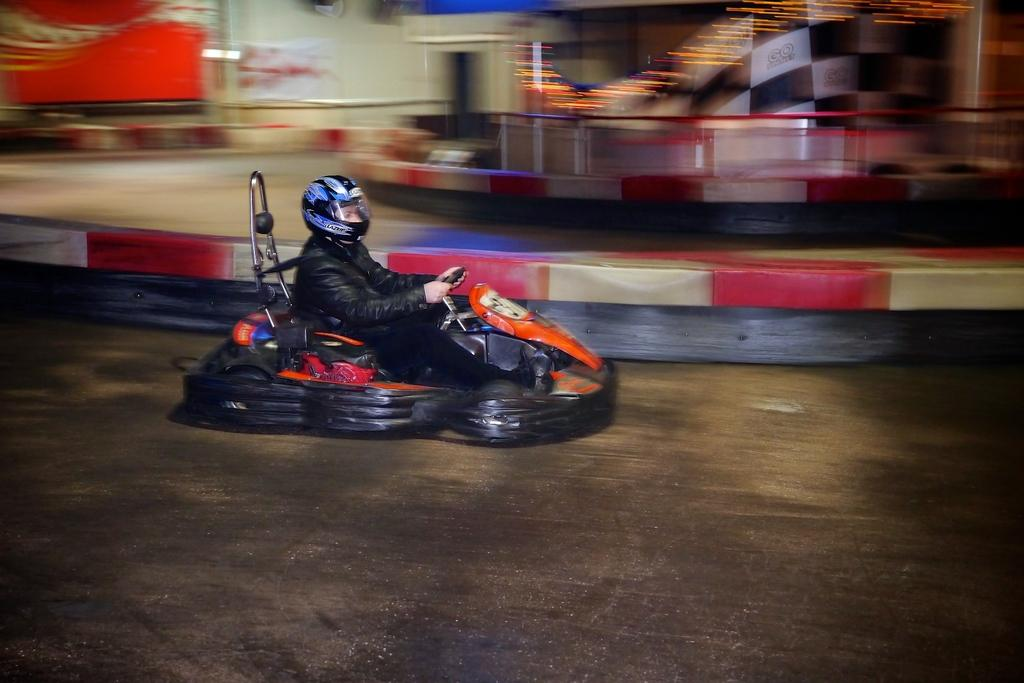What can be seen in the image? There is a person in the image, and they are wearing a helmet. What might the person be doing in the image? The person is riding something, possibly a bike or motorcycle, in the image. Can you describe the background of the image? The background is blurred, and there is a barrier, a path, a wall, and a banner visible. What part of the road can be seen in the image? The road is visible at the bottom of the image. What type of oatmeal is being served for dinner in the image? There is no oatmeal or dinner scene present in the image; it features a person riding something with a blurred background. Can you describe the bath setup in the image? There is no bath or bathing scene present in the image; it features a person riding something with a blurred background. 